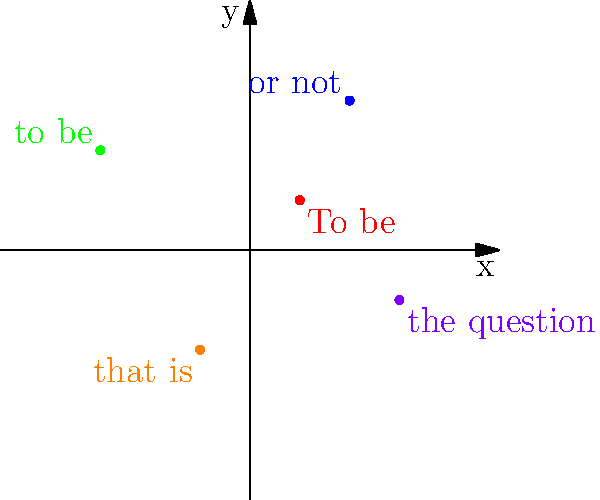In the coordinate plane above, famous words from Shakespeare's "Hamlet" have been plotted to create a visual representation of the quote "To be or not to be, that is the question." If we were to connect these points in the order they appear in the quote, what would be the total distance traveled, rounded to the nearest whole number? To solve this problem, we need to follow these steps:

1. Identify the coordinates of each point:
   "To be": (1, 1)
   "or not": (2, 3)
   "to be": (-3, 2)
   "that is": (-1, -2)
   "the question": (3, -1)

2. Calculate the distance between consecutive points using the distance formula:
   $d = \sqrt{(x_2 - x_1)^2 + (y_2 - y_1)^2}$

3. Distance from "To be" to "or not":
   $d_1 = \sqrt{(2 - 1)^2 + (3 - 1)^2} = \sqrt{5}$

4. Distance from "or not" to "to be":
   $d_2 = \sqrt{(-3 - 2)^2 + (2 - 3)^2} = \sqrt{26}$

5. Distance from "to be" to "that is":
   $d_3 = \sqrt{(-1 - (-3))^2 + (-2 - 2)^2} = \sqrt{20}$

6. Distance from "that is" to "the question":
   $d_4 = \sqrt{(3 - (-1))^2 + (-1 - (-2))^2} = \sqrt{17}$

7. Sum up all the distances:
   $d_{total} = \sqrt{5} + \sqrt{26} + \sqrt{20} + \sqrt{17}$

8. Calculate the sum and round to the nearest whole number:
   $d_{total} \approx 2.24 + 5.10 + 4.47 + 4.12 = 15.93$

9. Rounding to the nearest whole number:
   $d_{total} \approx 16$
Answer: 16 